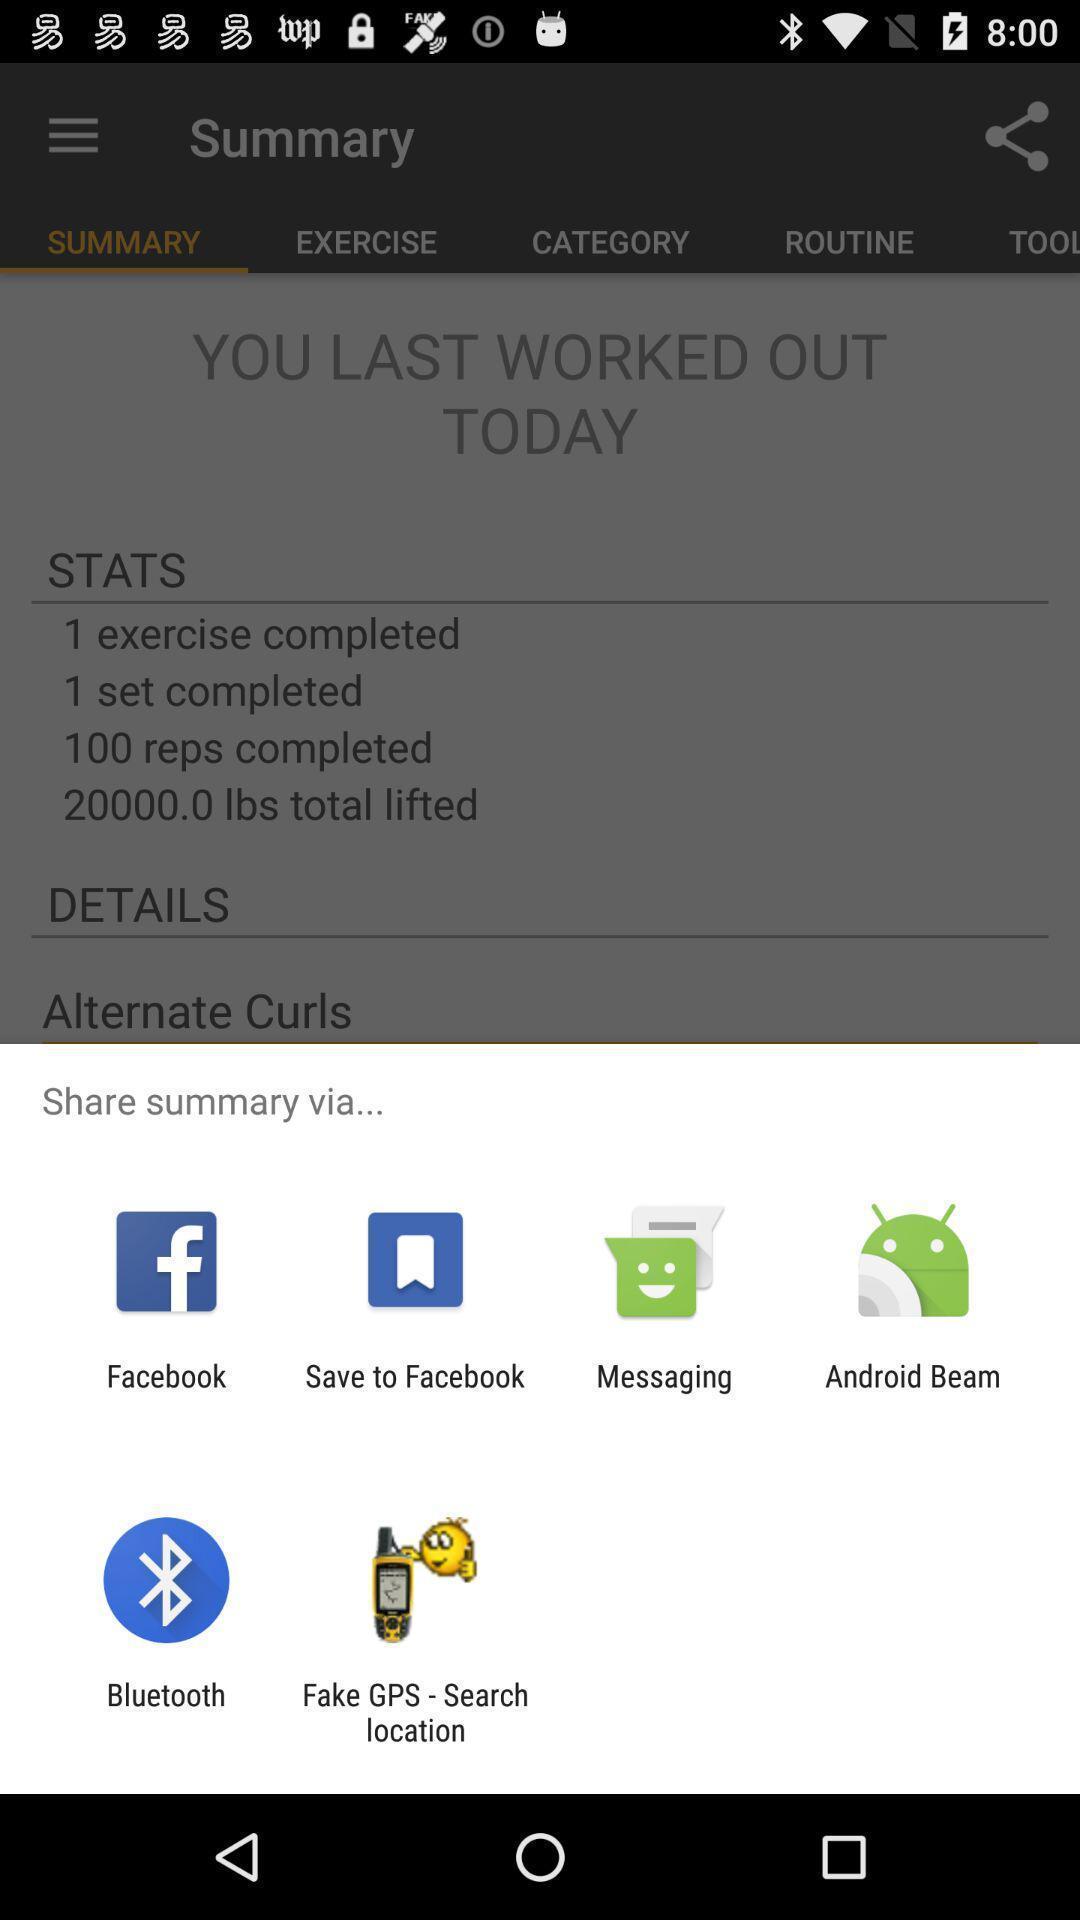Summarize the main components in this picture. Popup showing different apps to share. 